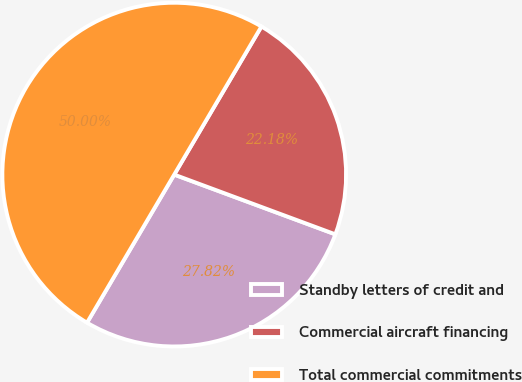Convert chart. <chart><loc_0><loc_0><loc_500><loc_500><pie_chart><fcel>Standby letters of credit and<fcel>Commercial aircraft financing<fcel>Total commercial commitments<nl><fcel>27.82%<fcel>22.18%<fcel>50.0%<nl></chart> 